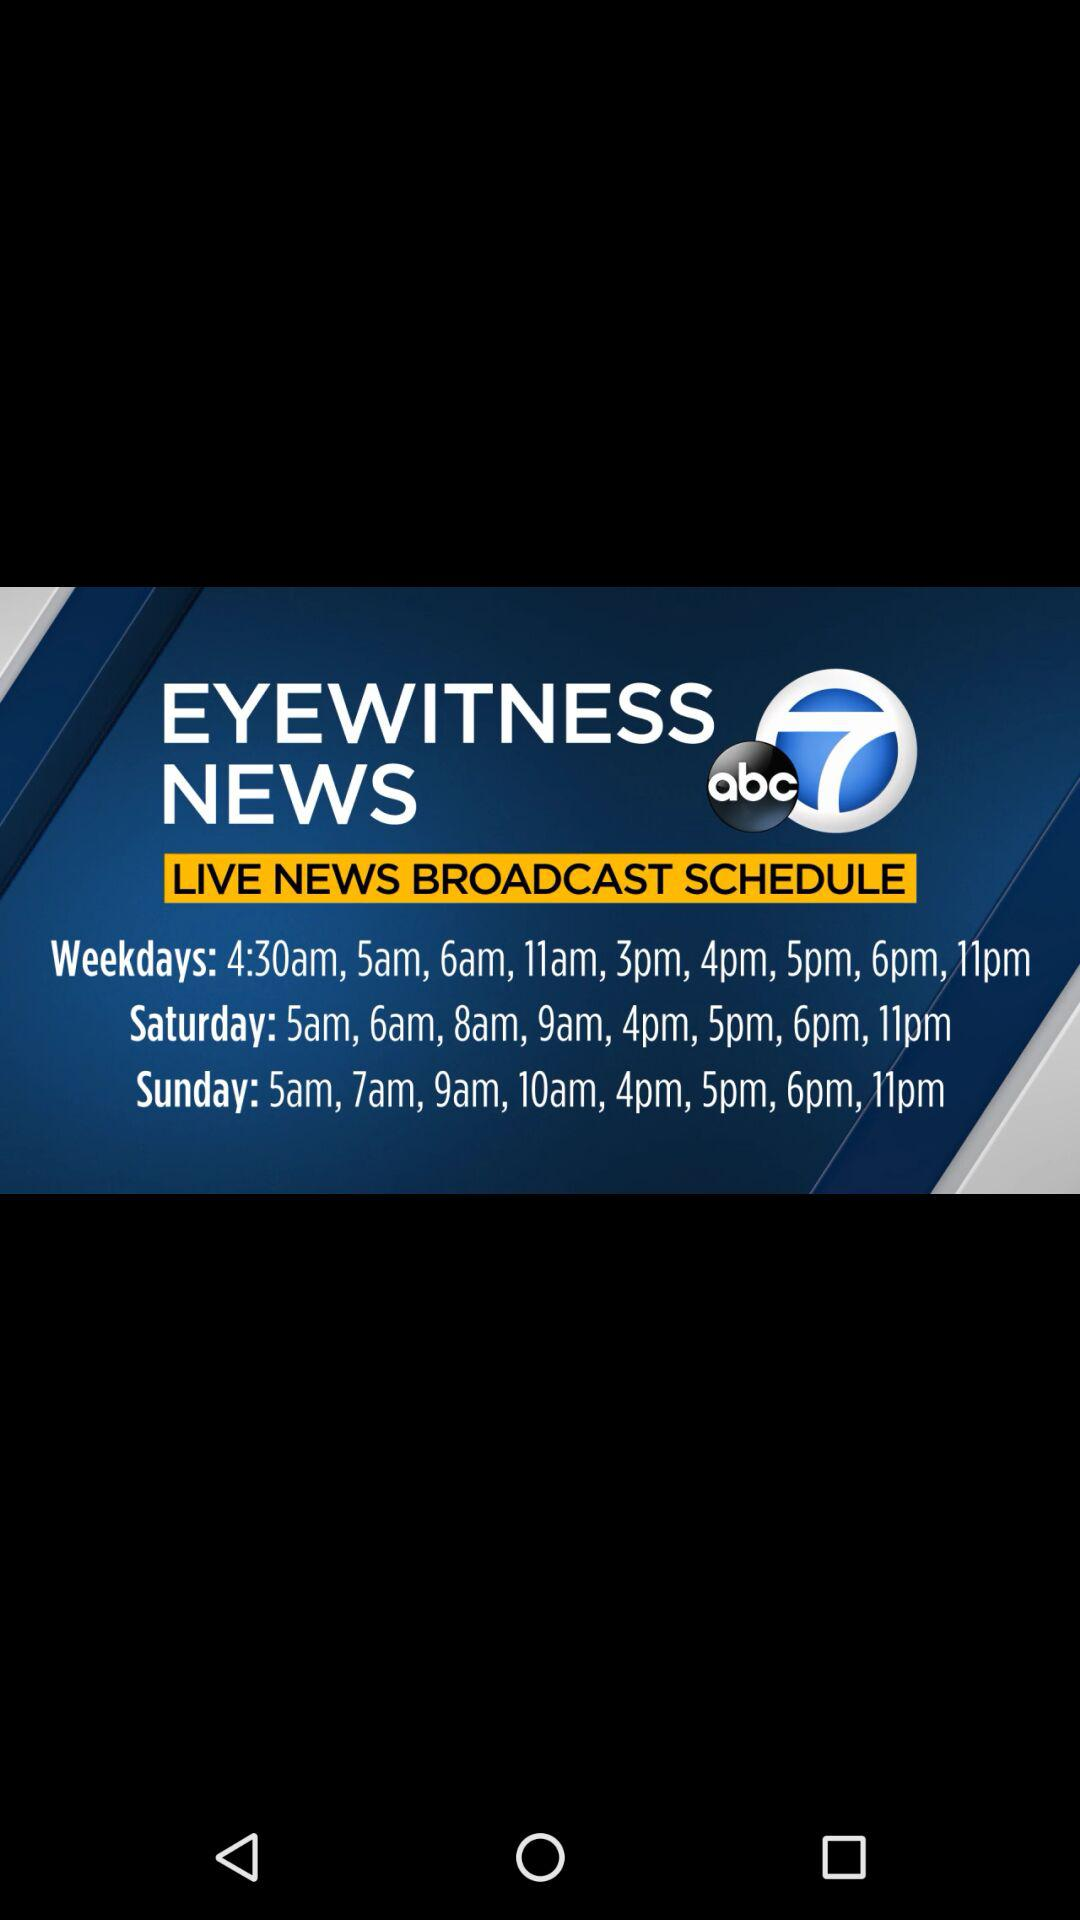What is the time of the first broadcast of the news on Sunday? The time of the first broadcast of the news on Sunday is 5 a.m. 